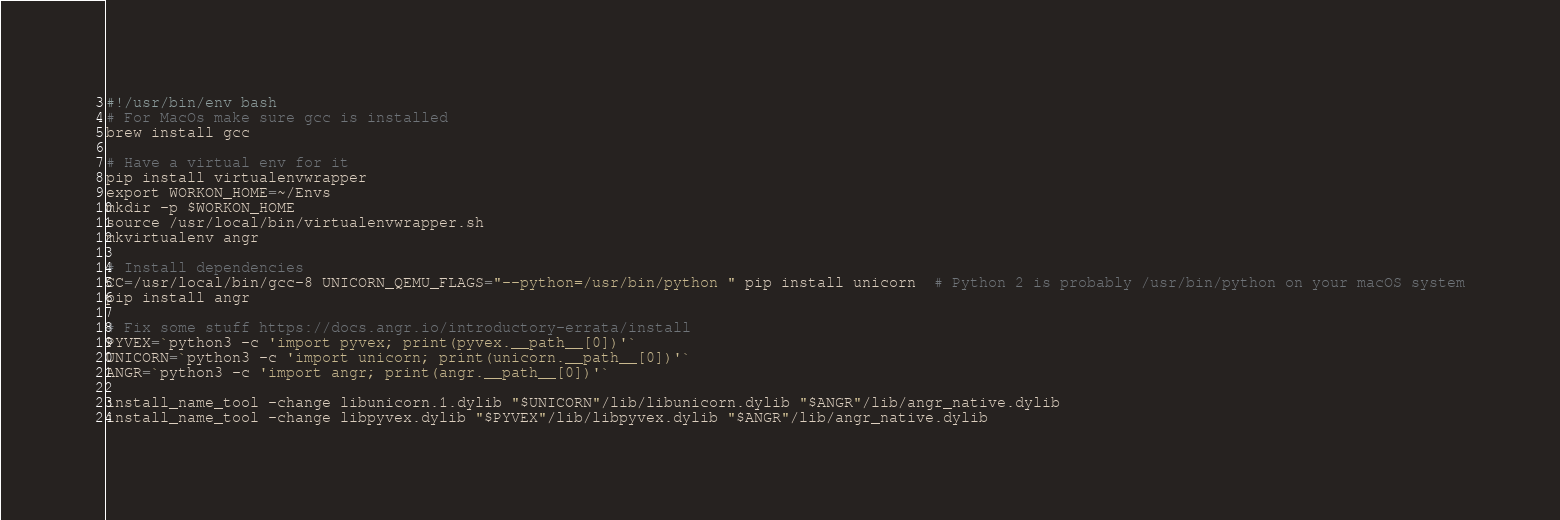Convert code to text. <code><loc_0><loc_0><loc_500><loc_500><_Bash_>#!/usr/bin/env bash
# For MacOs make sure gcc is installed
brew install gcc

# Have a virtual env for it
pip install virtualenvwrapper
export WORKON_HOME=~/Envs
mkdir -p $WORKON_HOME
source /usr/local/bin/virtualenvwrapper.sh
mkvirtualenv angr

# Install dependencies
CC=/usr/local/bin/gcc-8 UNICORN_QEMU_FLAGS="--python=/usr/bin/python " pip install unicorn  # Python 2 is probably /usr/bin/python on your macOS system
pip install angr

# Fix some stuff https://docs.angr.io/introductory-errata/install
PYVEX=`python3 -c 'import pyvex; print(pyvex.__path__[0])'`
UNICORN=`python3 -c 'import unicorn; print(unicorn.__path__[0])'`
ANGR=`python3 -c 'import angr; print(angr.__path__[0])'`

install_name_tool -change libunicorn.1.dylib "$UNICORN"/lib/libunicorn.dylib "$ANGR"/lib/angr_native.dylib
install_name_tool -change libpyvex.dylib "$PYVEX"/lib/libpyvex.dylib "$ANGR"/lib/angr_native.dylib</code> 